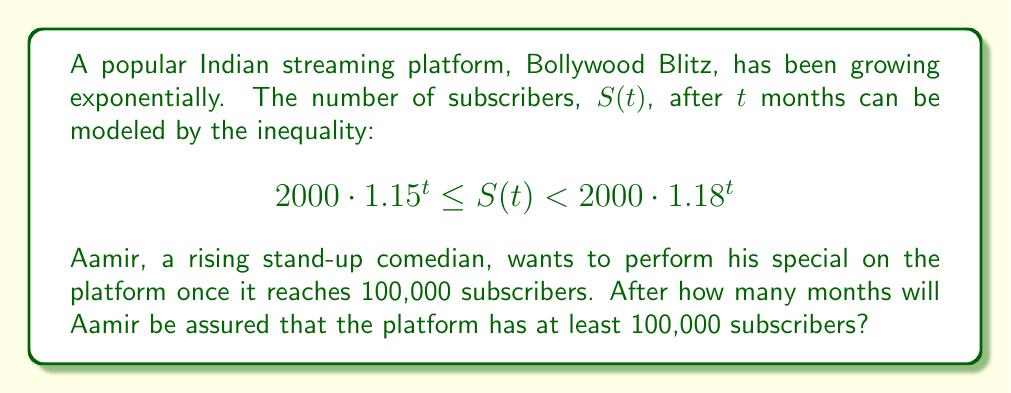Give your solution to this math problem. Let's approach this step-by-step:

1) We need to find when the lower bound of the inequality reaches 100,000:

   $$2000 \cdot 1.15^t \geq 100000$$

2) Divide both sides by 2000:

   $$1.15^t \geq 50$$

3) Take the natural log of both sides:

   $$t \cdot \ln(1.15) \geq \ln(50)$$

4) Solve for $t$:

   $$t \geq \frac{\ln(50)}{\ln(1.15)}$$

5) Calculate this value:

   $$t \geq 26.92$$

6) Since $t$ represents months, we need to round up to the nearest whole number:

   $$t \geq 27$$

Therefore, after 27 months, Aamir can be assured that Bollywood Blitz has at least 100,000 subscribers.

7) We can verify this by plugging 27 into our original inequality:

   $$2000 \cdot 1.15^{27} \approx 100,912$$
   $$2000 \cdot 1.18^{27} \approx 131,547$$

   Indeed, both bounds are above 100,000 at $t = 27$.
Answer: 27 months 